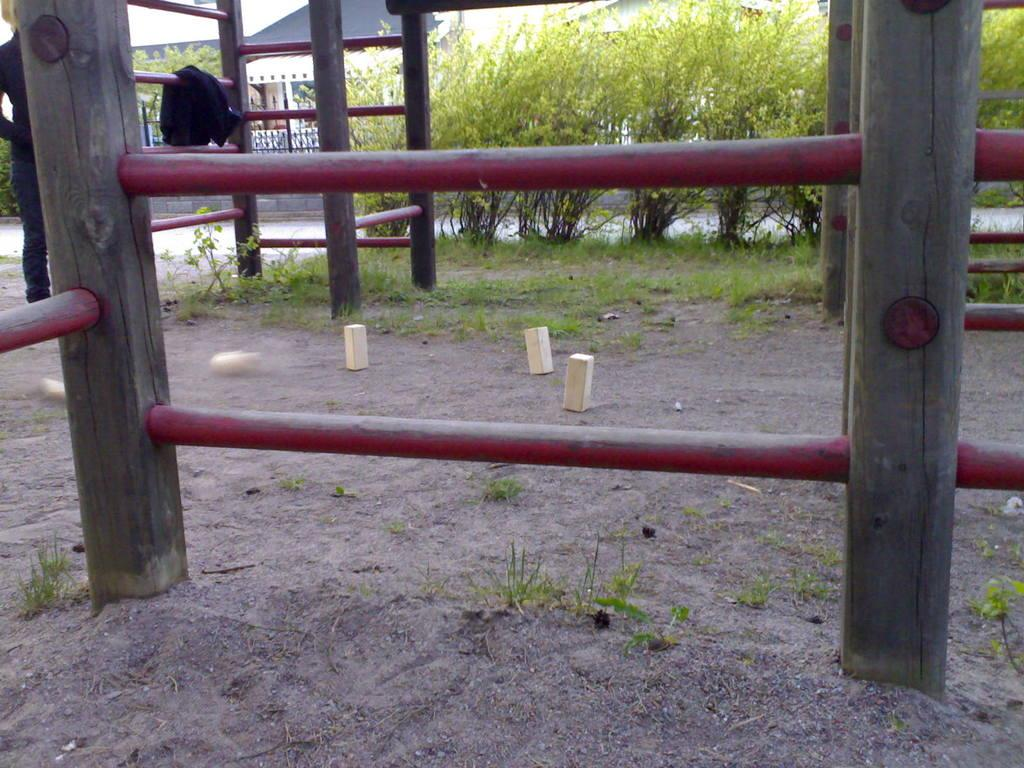What type of material is used for the logs in the image? The logs in the image are made of wood. What other structures can be seen in the image? There are metal pole structures in the image. What type of vegetation is visible in the image? There is grass and plants visible in the image. What type of building is present in the image? There is a house in the image. How many sheep are grazing in the grass in the image? There are no sheep present in the image. What level of respect can be observed between the wooden logs and the metal pole structures in the image? There is no indication of respect or interaction between the wooden logs and the metal pole structures in the image. 